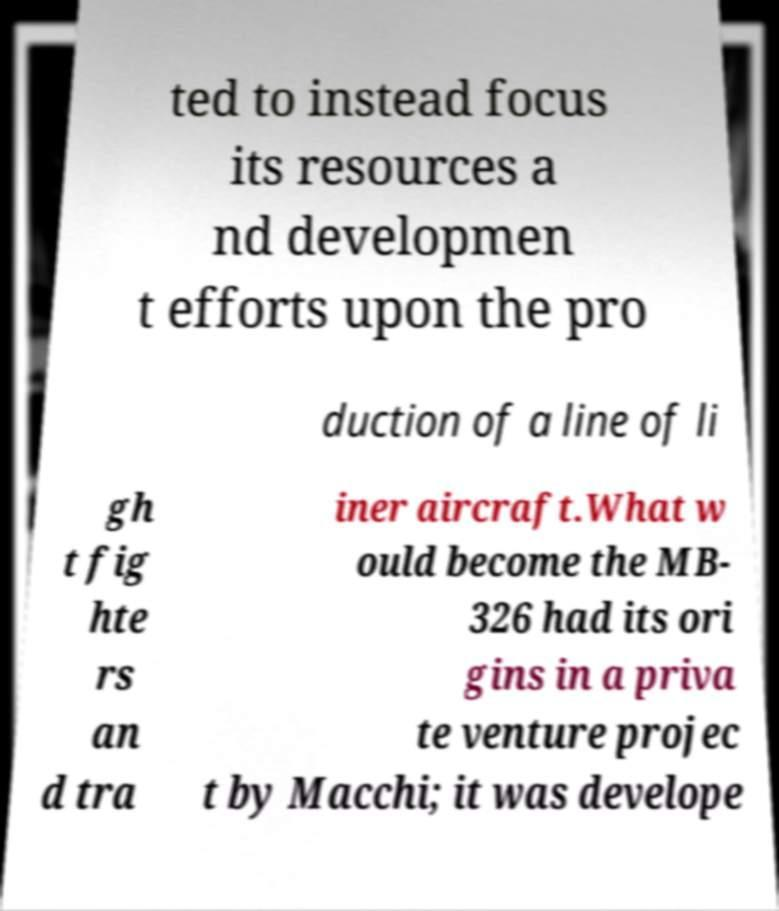Could you assist in decoding the text presented in this image and type it out clearly? ted to instead focus its resources a nd developmen t efforts upon the pro duction of a line of li gh t fig hte rs an d tra iner aircraft.What w ould become the MB- 326 had its ori gins in a priva te venture projec t by Macchi; it was develope 